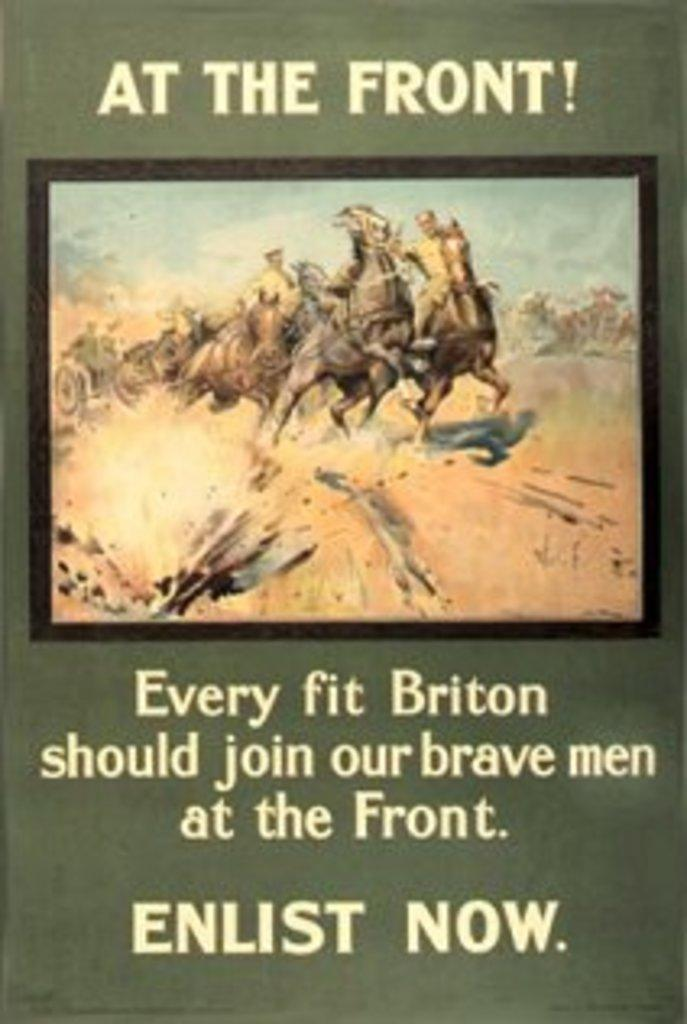<image>
Provide a brief description of the given image. Green cover that tells people to Enlist Now on the bottom. 